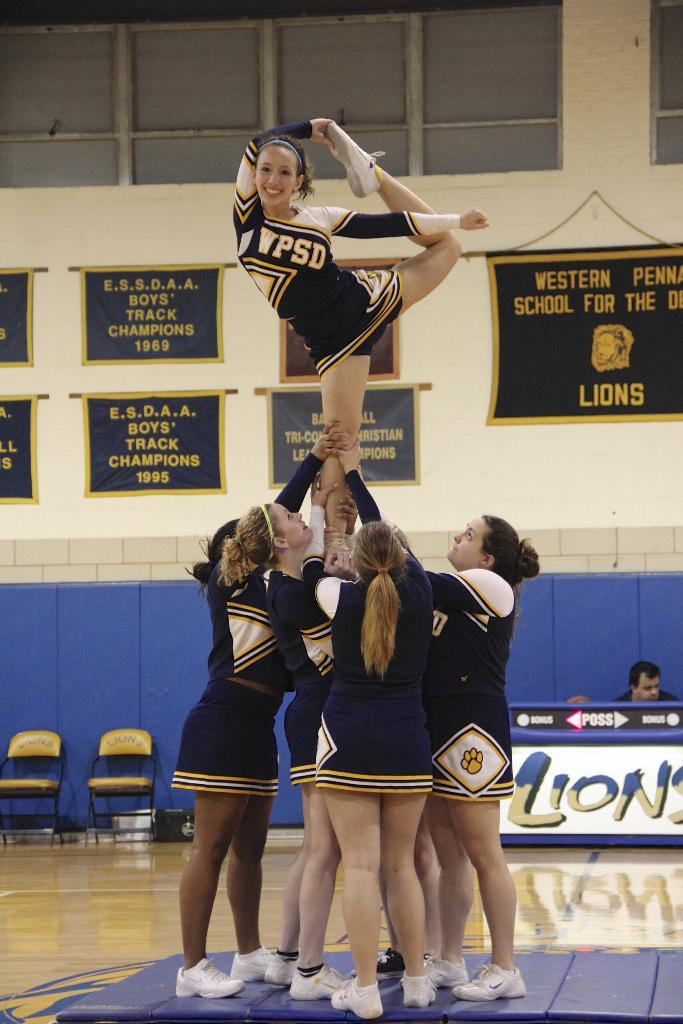<image>
Give a short and clear explanation of the subsequent image. cheerleaders for WPSD perform a stunt on the court 